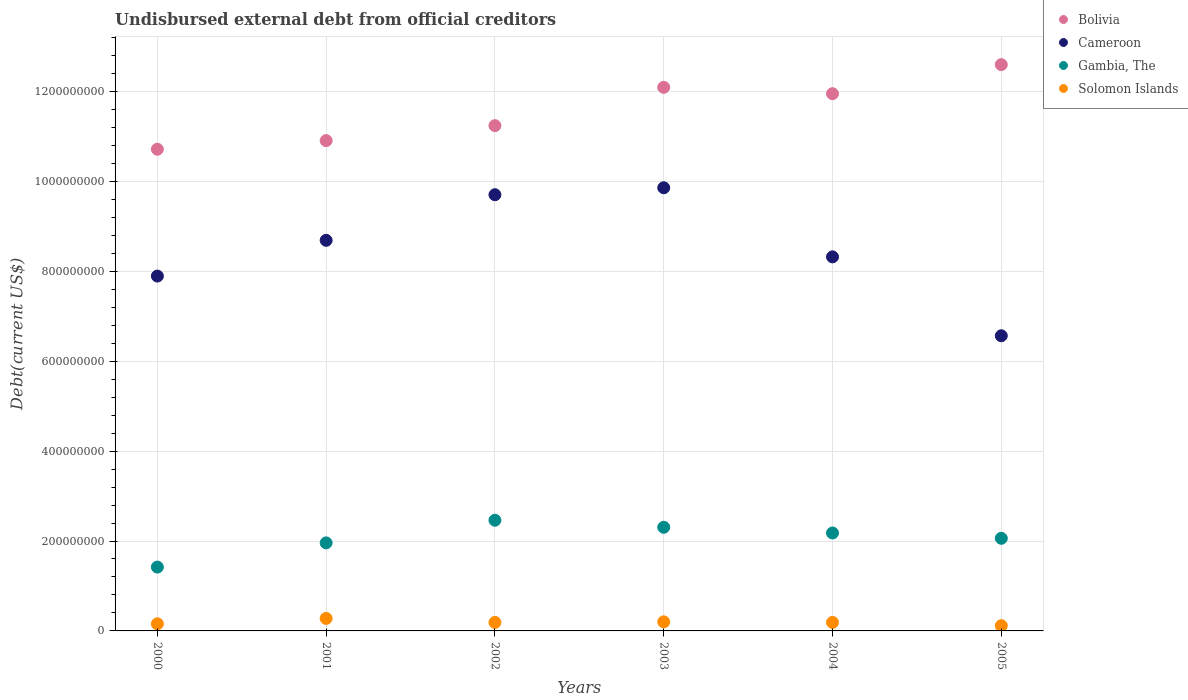How many different coloured dotlines are there?
Ensure brevity in your answer.  4. Is the number of dotlines equal to the number of legend labels?
Ensure brevity in your answer.  Yes. What is the total debt in Cameroon in 2004?
Provide a short and direct response. 8.32e+08. Across all years, what is the maximum total debt in Gambia, The?
Give a very brief answer. 2.46e+08. Across all years, what is the minimum total debt in Gambia, The?
Provide a short and direct response. 1.42e+08. What is the total total debt in Solomon Islands in the graph?
Provide a short and direct response. 1.13e+08. What is the difference between the total debt in Bolivia in 2000 and that in 2002?
Provide a short and direct response. -5.24e+07. What is the difference between the total debt in Cameroon in 2004 and the total debt in Gambia, The in 2005?
Offer a very short reply. 6.26e+08. What is the average total debt in Solomon Islands per year?
Provide a succinct answer. 1.89e+07. In the year 2001, what is the difference between the total debt in Solomon Islands and total debt in Gambia, The?
Give a very brief answer. -1.68e+08. In how many years, is the total debt in Bolivia greater than 1120000000 US$?
Give a very brief answer. 4. What is the ratio of the total debt in Bolivia in 2001 to that in 2003?
Ensure brevity in your answer.  0.9. Is the total debt in Solomon Islands in 2003 less than that in 2005?
Offer a terse response. No. What is the difference between the highest and the second highest total debt in Cameroon?
Your answer should be compact. 1.55e+07. What is the difference between the highest and the lowest total debt in Gambia, The?
Your response must be concise. 1.04e+08. Is the sum of the total debt in Gambia, The in 2002 and 2004 greater than the maximum total debt in Solomon Islands across all years?
Your answer should be compact. Yes. Is it the case that in every year, the sum of the total debt in Solomon Islands and total debt in Gambia, The  is greater than the total debt in Bolivia?
Offer a terse response. No. Does the total debt in Gambia, The monotonically increase over the years?
Your response must be concise. No. Is the total debt in Solomon Islands strictly greater than the total debt in Cameroon over the years?
Give a very brief answer. No. Is the total debt in Solomon Islands strictly less than the total debt in Bolivia over the years?
Keep it short and to the point. Yes. How many dotlines are there?
Offer a very short reply. 4. What is the difference between two consecutive major ticks on the Y-axis?
Make the answer very short. 2.00e+08. Does the graph contain grids?
Provide a short and direct response. Yes. How many legend labels are there?
Offer a terse response. 4. What is the title of the graph?
Provide a succinct answer. Undisbursed external debt from official creditors. What is the label or title of the Y-axis?
Offer a very short reply. Debt(current US$). What is the Debt(current US$) in Bolivia in 2000?
Provide a short and direct response. 1.07e+09. What is the Debt(current US$) in Cameroon in 2000?
Your response must be concise. 7.89e+08. What is the Debt(current US$) of Gambia, The in 2000?
Make the answer very short. 1.42e+08. What is the Debt(current US$) of Solomon Islands in 2000?
Your response must be concise. 1.58e+07. What is the Debt(current US$) in Bolivia in 2001?
Give a very brief answer. 1.09e+09. What is the Debt(current US$) of Cameroon in 2001?
Your answer should be very brief. 8.69e+08. What is the Debt(current US$) in Gambia, The in 2001?
Give a very brief answer. 1.96e+08. What is the Debt(current US$) in Solomon Islands in 2001?
Give a very brief answer. 2.78e+07. What is the Debt(current US$) in Bolivia in 2002?
Make the answer very short. 1.12e+09. What is the Debt(current US$) in Cameroon in 2002?
Offer a very short reply. 9.70e+08. What is the Debt(current US$) in Gambia, The in 2002?
Make the answer very short. 2.46e+08. What is the Debt(current US$) in Solomon Islands in 2002?
Offer a very short reply. 1.89e+07. What is the Debt(current US$) in Bolivia in 2003?
Give a very brief answer. 1.21e+09. What is the Debt(current US$) of Cameroon in 2003?
Provide a short and direct response. 9.86e+08. What is the Debt(current US$) of Gambia, The in 2003?
Provide a succinct answer. 2.31e+08. What is the Debt(current US$) in Solomon Islands in 2003?
Your answer should be very brief. 2.02e+07. What is the Debt(current US$) of Bolivia in 2004?
Make the answer very short. 1.19e+09. What is the Debt(current US$) of Cameroon in 2004?
Make the answer very short. 8.32e+08. What is the Debt(current US$) in Gambia, The in 2004?
Keep it short and to the point. 2.18e+08. What is the Debt(current US$) in Solomon Islands in 2004?
Offer a very short reply. 1.89e+07. What is the Debt(current US$) of Bolivia in 2005?
Your answer should be very brief. 1.26e+09. What is the Debt(current US$) of Cameroon in 2005?
Keep it short and to the point. 6.57e+08. What is the Debt(current US$) in Gambia, The in 2005?
Give a very brief answer. 2.06e+08. What is the Debt(current US$) in Solomon Islands in 2005?
Offer a terse response. 1.17e+07. Across all years, what is the maximum Debt(current US$) in Bolivia?
Provide a short and direct response. 1.26e+09. Across all years, what is the maximum Debt(current US$) in Cameroon?
Provide a short and direct response. 9.86e+08. Across all years, what is the maximum Debt(current US$) of Gambia, The?
Your answer should be very brief. 2.46e+08. Across all years, what is the maximum Debt(current US$) of Solomon Islands?
Keep it short and to the point. 2.78e+07. Across all years, what is the minimum Debt(current US$) in Bolivia?
Your response must be concise. 1.07e+09. Across all years, what is the minimum Debt(current US$) in Cameroon?
Keep it short and to the point. 6.57e+08. Across all years, what is the minimum Debt(current US$) of Gambia, The?
Ensure brevity in your answer.  1.42e+08. Across all years, what is the minimum Debt(current US$) in Solomon Islands?
Provide a short and direct response. 1.17e+07. What is the total Debt(current US$) of Bolivia in the graph?
Your answer should be compact. 6.95e+09. What is the total Debt(current US$) in Cameroon in the graph?
Keep it short and to the point. 5.10e+09. What is the total Debt(current US$) of Gambia, The in the graph?
Your answer should be compact. 1.24e+09. What is the total Debt(current US$) in Solomon Islands in the graph?
Your response must be concise. 1.13e+08. What is the difference between the Debt(current US$) of Bolivia in 2000 and that in 2001?
Your answer should be compact. -1.92e+07. What is the difference between the Debt(current US$) in Cameroon in 2000 and that in 2001?
Provide a short and direct response. -7.95e+07. What is the difference between the Debt(current US$) of Gambia, The in 2000 and that in 2001?
Make the answer very short. -5.39e+07. What is the difference between the Debt(current US$) in Solomon Islands in 2000 and that in 2001?
Keep it short and to the point. -1.20e+07. What is the difference between the Debt(current US$) of Bolivia in 2000 and that in 2002?
Provide a short and direct response. -5.24e+07. What is the difference between the Debt(current US$) in Cameroon in 2000 and that in 2002?
Give a very brief answer. -1.81e+08. What is the difference between the Debt(current US$) in Gambia, The in 2000 and that in 2002?
Give a very brief answer. -1.04e+08. What is the difference between the Debt(current US$) of Solomon Islands in 2000 and that in 2002?
Ensure brevity in your answer.  -3.08e+06. What is the difference between the Debt(current US$) of Bolivia in 2000 and that in 2003?
Ensure brevity in your answer.  -1.38e+08. What is the difference between the Debt(current US$) in Cameroon in 2000 and that in 2003?
Make the answer very short. -1.96e+08. What is the difference between the Debt(current US$) in Gambia, The in 2000 and that in 2003?
Offer a very short reply. -8.85e+07. What is the difference between the Debt(current US$) of Solomon Islands in 2000 and that in 2003?
Ensure brevity in your answer.  -4.37e+06. What is the difference between the Debt(current US$) of Bolivia in 2000 and that in 2004?
Give a very brief answer. -1.24e+08. What is the difference between the Debt(current US$) in Cameroon in 2000 and that in 2004?
Keep it short and to the point. -4.27e+07. What is the difference between the Debt(current US$) of Gambia, The in 2000 and that in 2004?
Your answer should be very brief. -7.58e+07. What is the difference between the Debt(current US$) of Solomon Islands in 2000 and that in 2004?
Ensure brevity in your answer.  -3.07e+06. What is the difference between the Debt(current US$) of Bolivia in 2000 and that in 2005?
Provide a succinct answer. -1.88e+08. What is the difference between the Debt(current US$) of Cameroon in 2000 and that in 2005?
Keep it short and to the point. 1.33e+08. What is the difference between the Debt(current US$) of Gambia, The in 2000 and that in 2005?
Keep it short and to the point. -6.40e+07. What is the difference between the Debt(current US$) of Solomon Islands in 2000 and that in 2005?
Provide a short and direct response. 4.14e+06. What is the difference between the Debt(current US$) of Bolivia in 2001 and that in 2002?
Provide a short and direct response. -3.33e+07. What is the difference between the Debt(current US$) of Cameroon in 2001 and that in 2002?
Make the answer very short. -1.01e+08. What is the difference between the Debt(current US$) in Gambia, The in 2001 and that in 2002?
Provide a succinct answer. -5.03e+07. What is the difference between the Debt(current US$) in Solomon Islands in 2001 and that in 2002?
Your answer should be very brief. 8.89e+06. What is the difference between the Debt(current US$) of Bolivia in 2001 and that in 2003?
Provide a short and direct response. -1.18e+08. What is the difference between the Debt(current US$) in Cameroon in 2001 and that in 2003?
Offer a terse response. -1.17e+08. What is the difference between the Debt(current US$) of Gambia, The in 2001 and that in 2003?
Your answer should be compact. -3.47e+07. What is the difference between the Debt(current US$) in Solomon Islands in 2001 and that in 2003?
Make the answer very short. 7.60e+06. What is the difference between the Debt(current US$) of Bolivia in 2001 and that in 2004?
Provide a short and direct response. -1.04e+08. What is the difference between the Debt(current US$) in Cameroon in 2001 and that in 2004?
Your response must be concise. 3.68e+07. What is the difference between the Debt(current US$) of Gambia, The in 2001 and that in 2004?
Your answer should be compact. -2.20e+07. What is the difference between the Debt(current US$) of Solomon Islands in 2001 and that in 2004?
Ensure brevity in your answer.  8.90e+06. What is the difference between the Debt(current US$) of Bolivia in 2001 and that in 2005?
Provide a short and direct response. -1.69e+08. What is the difference between the Debt(current US$) in Cameroon in 2001 and that in 2005?
Your answer should be compact. 2.12e+08. What is the difference between the Debt(current US$) of Gambia, The in 2001 and that in 2005?
Your response must be concise. -1.02e+07. What is the difference between the Debt(current US$) in Solomon Islands in 2001 and that in 2005?
Provide a short and direct response. 1.61e+07. What is the difference between the Debt(current US$) in Bolivia in 2002 and that in 2003?
Your response must be concise. -8.52e+07. What is the difference between the Debt(current US$) in Cameroon in 2002 and that in 2003?
Offer a very short reply. -1.55e+07. What is the difference between the Debt(current US$) in Gambia, The in 2002 and that in 2003?
Keep it short and to the point. 1.56e+07. What is the difference between the Debt(current US$) in Solomon Islands in 2002 and that in 2003?
Offer a very short reply. -1.30e+06. What is the difference between the Debt(current US$) of Bolivia in 2002 and that in 2004?
Your response must be concise. -7.11e+07. What is the difference between the Debt(current US$) in Cameroon in 2002 and that in 2004?
Ensure brevity in your answer.  1.38e+08. What is the difference between the Debt(current US$) of Gambia, The in 2002 and that in 2004?
Make the answer very short. 2.83e+07. What is the difference between the Debt(current US$) in Solomon Islands in 2002 and that in 2004?
Provide a short and direct response. 9000. What is the difference between the Debt(current US$) of Bolivia in 2002 and that in 2005?
Your response must be concise. -1.36e+08. What is the difference between the Debt(current US$) in Cameroon in 2002 and that in 2005?
Offer a terse response. 3.14e+08. What is the difference between the Debt(current US$) in Gambia, The in 2002 and that in 2005?
Offer a terse response. 4.01e+07. What is the difference between the Debt(current US$) in Solomon Islands in 2002 and that in 2005?
Offer a very short reply. 7.22e+06. What is the difference between the Debt(current US$) of Bolivia in 2003 and that in 2004?
Provide a short and direct response. 1.41e+07. What is the difference between the Debt(current US$) in Cameroon in 2003 and that in 2004?
Your response must be concise. 1.54e+08. What is the difference between the Debt(current US$) in Gambia, The in 2003 and that in 2004?
Ensure brevity in your answer.  1.27e+07. What is the difference between the Debt(current US$) of Solomon Islands in 2003 and that in 2004?
Give a very brief answer. 1.30e+06. What is the difference between the Debt(current US$) in Bolivia in 2003 and that in 2005?
Ensure brevity in your answer.  -5.05e+07. What is the difference between the Debt(current US$) of Cameroon in 2003 and that in 2005?
Provide a short and direct response. 3.29e+08. What is the difference between the Debt(current US$) in Gambia, The in 2003 and that in 2005?
Make the answer very short. 2.45e+07. What is the difference between the Debt(current US$) of Solomon Islands in 2003 and that in 2005?
Your answer should be very brief. 8.52e+06. What is the difference between the Debt(current US$) in Bolivia in 2004 and that in 2005?
Provide a short and direct response. -6.46e+07. What is the difference between the Debt(current US$) of Cameroon in 2004 and that in 2005?
Your answer should be very brief. 1.76e+08. What is the difference between the Debt(current US$) in Gambia, The in 2004 and that in 2005?
Your answer should be very brief. 1.18e+07. What is the difference between the Debt(current US$) of Solomon Islands in 2004 and that in 2005?
Ensure brevity in your answer.  7.21e+06. What is the difference between the Debt(current US$) in Bolivia in 2000 and the Debt(current US$) in Cameroon in 2001?
Offer a terse response. 2.03e+08. What is the difference between the Debt(current US$) in Bolivia in 2000 and the Debt(current US$) in Gambia, The in 2001?
Your response must be concise. 8.76e+08. What is the difference between the Debt(current US$) in Bolivia in 2000 and the Debt(current US$) in Solomon Islands in 2001?
Give a very brief answer. 1.04e+09. What is the difference between the Debt(current US$) in Cameroon in 2000 and the Debt(current US$) in Gambia, The in 2001?
Give a very brief answer. 5.93e+08. What is the difference between the Debt(current US$) of Cameroon in 2000 and the Debt(current US$) of Solomon Islands in 2001?
Offer a terse response. 7.62e+08. What is the difference between the Debt(current US$) in Gambia, The in 2000 and the Debt(current US$) in Solomon Islands in 2001?
Offer a very short reply. 1.14e+08. What is the difference between the Debt(current US$) of Bolivia in 2000 and the Debt(current US$) of Cameroon in 2002?
Keep it short and to the point. 1.01e+08. What is the difference between the Debt(current US$) in Bolivia in 2000 and the Debt(current US$) in Gambia, The in 2002?
Offer a terse response. 8.25e+08. What is the difference between the Debt(current US$) of Bolivia in 2000 and the Debt(current US$) of Solomon Islands in 2002?
Your answer should be compact. 1.05e+09. What is the difference between the Debt(current US$) of Cameroon in 2000 and the Debt(current US$) of Gambia, The in 2002?
Provide a short and direct response. 5.43e+08. What is the difference between the Debt(current US$) in Cameroon in 2000 and the Debt(current US$) in Solomon Islands in 2002?
Ensure brevity in your answer.  7.70e+08. What is the difference between the Debt(current US$) in Gambia, The in 2000 and the Debt(current US$) in Solomon Islands in 2002?
Give a very brief answer. 1.23e+08. What is the difference between the Debt(current US$) in Bolivia in 2000 and the Debt(current US$) in Cameroon in 2003?
Make the answer very short. 8.57e+07. What is the difference between the Debt(current US$) of Bolivia in 2000 and the Debt(current US$) of Gambia, The in 2003?
Make the answer very short. 8.41e+08. What is the difference between the Debt(current US$) in Bolivia in 2000 and the Debt(current US$) in Solomon Islands in 2003?
Keep it short and to the point. 1.05e+09. What is the difference between the Debt(current US$) of Cameroon in 2000 and the Debt(current US$) of Gambia, The in 2003?
Ensure brevity in your answer.  5.59e+08. What is the difference between the Debt(current US$) of Cameroon in 2000 and the Debt(current US$) of Solomon Islands in 2003?
Ensure brevity in your answer.  7.69e+08. What is the difference between the Debt(current US$) in Gambia, The in 2000 and the Debt(current US$) in Solomon Islands in 2003?
Give a very brief answer. 1.22e+08. What is the difference between the Debt(current US$) in Bolivia in 2000 and the Debt(current US$) in Cameroon in 2004?
Provide a short and direct response. 2.39e+08. What is the difference between the Debt(current US$) of Bolivia in 2000 and the Debt(current US$) of Gambia, The in 2004?
Your answer should be very brief. 8.54e+08. What is the difference between the Debt(current US$) of Bolivia in 2000 and the Debt(current US$) of Solomon Islands in 2004?
Offer a terse response. 1.05e+09. What is the difference between the Debt(current US$) in Cameroon in 2000 and the Debt(current US$) in Gambia, The in 2004?
Your answer should be compact. 5.71e+08. What is the difference between the Debt(current US$) of Cameroon in 2000 and the Debt(current US$) of Solomon Islands in 2004?
Offer a very short reply. 7.70e+08. What is the difference between the Debt(current US$) of Gambia, The in 2000 and the Debt(current US$) of Solomon Islands in 2004?
Your response must be concise. 1.23e+08. What is the difference between the Debt(current US$) in Bolivia in 2000 and the Debt(current US$) in Cameroon in 2005?
Offer a terse response. 4.15e+08. What is the difference between the Debt(current US$) in Bolivia in 2000 and the Debt(current US$) in Gambia, The in 2005?
Give a very brief answer. 8.65e+08. What is the difference between the Debt(current US$) in Bolivia in 2000 and the Debt(current US$) in Solomon Islands in 2005?
Give a very brief answer. 1.06e+09. What is the difference between the Debt(current US$) of Cameroon in 2000 and the Debt(current US$) of Gambia, The in 2005?
Provide a succinct answer. 5.83e+08. What is the difference between the Debt(current US$) of Cameroon in 2000 and the Debt(current US$) of Solomon Islands in 2005?
Your answer should be compact. 7.78e+08. What is the difference between the Debt(current US$) of Gambia, The in 2000 and the Debt(current US$) of Solomon Islands in 2005?
Provide a short and direct response. 1.30e+08. What is the difference between the Debt(current US$) in Bolivia in 2001 and the Debt(current US$) in Cameroon in 2002?
Keep it short and to the point. 1.20e+08. What is the difference between the Debt(current US$) in Bolivia in 2001 and the Debt(current US$) in Gambia, The in 2002?
Offer a very short reply. 8.44e+08. What is the difference between the Debt(current US$) in Bolivia in 2001 and the Debt(current US$) in Solomon Islands in 2002?
Provide a short and direct response. 1.07e+09. What is the difference between the Debt(current US$) in Cameroon in 2001 and the Debt(current US$) in Gambia, The in 2002?
Provide a short and direct response. 6.23e+08. What is the difference between the Debt(current US$) in Cameroon in 2001 and the Debt(current US$) in Solomon Islands in 2002?
Provide a short and direct response. 8.50e+08. What is the difference between the Debt(current US$) of Gambia, The in 2001 and the Debt(current US$) of Solomon Islands in 2002?
Your answer should be very brief. 1.77e+08. What is the difference between the Debt(current US$) of Bolivia in 2001 and the Debt(current US$) of Cameroon in 2003?
Provide a short and direct response. 1.05e+08. What is the difference between the Debt(current US$) of Bolivia in 2001 and the Debt(current US$) of Gambia, The in 2003?
Keep it short and to the point. 8.60e+08. What is the difference between the Debt(current US$) in Bolivia in 2001 and the Debt(current US$) in Solomon Islands in 2003?
Your answer should be very brief. 1.07e+09. What is the difference between the Debt(current US$) in Cameroon in 2001 and the Debt(current US$) in Gambia, The in 2003?
Make the answer very short. 6.38e+08. What is the difference between the Debt(current US$) in Cameroon in 2001 and the Debt(current US$) in Solomon Islands in 2003?
Keep it short and to the point. 8.49e+08. What is the difference between the Debt(current US$) in Gambia, The in 2001 and the Debt(current US$) in Solomon Islands in 2003?
Keep it short and to the point. 1.76e+08. What is the difference between the Debt(current US$) of Bolivia in 2001 and the Debt(current US$) of Cameroon in 2004?
Your answer should be very brief. 2.59e+08. What is the difference between the Debt(current US$) in Bolivia in 2001 and the Debt(current US$) in Gambia, The in 2004?
Give a very brief answer. 8.73e+08. What is the difference between the Debt(current US$) in Bolivia in 2001 and the Debt(current US$) in Solomon Islands in 2004?
Your answer should be very brief. 1.07e+09. What is the difference between the Debt(current US$) of Cameroon in 2001 and the Debt(current US$) of Gambia, The in 2004?
Make the answer very short. 6.51e+08. What is the difference between the Debt(current US$) of Cameroon in 2001 and the Debt(current US$) of Solomon Islands in 2004?
Ensure brevity in your answer.  8.50e+08. What is the difference between the Debt(current US$) of Gambia, The in 2001 and the Debt(current US$) of Solomon Islands in 2004?
Make the answer very short. 1.77e+08. What is the difference between the Debt(current US$) of Bolivia in 2001 and the Debt(current US$) of Cameroon in 2005?
Offer a very short reply. 4.34e+08. What is the difference between the Debt(current US$) in Bolivia in 2001 and the Debt(current US$) in Gambia, The in 2005?
Offer a very short reply. 8.85e+08. What is the difference between the Debt(current US$) in Bolivia in 2001 and the Debt(current US$) in Solomon Islands in 2005?
Make the answer very short. 1.08e+09. What is the difference between the Debt(current US$) of Cameroon in 2001 and the Debt(current US$) of Gambia, The in 2005?
Your answer should be very brief. 6.63e+08. What is the difference between the Debt(current US$) of Cameroon in 2001 and the Debt(current US$) of Solomon Islands in 2005?
Provide a short and direct response. 8.57e+08. What is the difference between the Debt(current US$) in Gambia, The in 2001 and the Debt(current US$) in Solomon Islands in 2005?
Provide a succinct answer. 1.84e+08. What is the difference between the Debt(current US$) in Bolivia in 2002 and the Debt(current US$) in Cameroon in 2003?
Offer a terse response. 1.38e+08. What is the difference between the Debt(current US$) in Bolivia in 2002 and the Debt(current US$) in Gambia, The in 2003?
Make the answer very short. 8.93e+08. What is the difference between the Debt(current US$) in Bolivia in 2002 and the Debt(current US$) in Solomon Islands in 2003?
Offer a terse response. 1.10e+09. What is the difference between the Debt(current US$) in Cameroon in 2002 and the Debt(current US$) in Gambia, The in 2003?
Your response must be concise. 7.40e+08. What is the difference between the Debt(current US$) of Cameroon in 2002 and the Debt(current US$) of Solomon Islands in 2003?
Keep it short and to the point. 9.50e+08. What is the difference between the Debt(current US$) in Gambia, The in 2002 and the Debt(current US$) in Solomon Islands in 2003?
Keep it short and to the point. 2.26e+08. What is the difference between the Debt(current US$) of Bolivia in 2002 and the Debt(current US$) of Cameroon in 2004?
Provide a short and direct response. 2.92e+08. What is the difference between the Debt(current US$) of Bolivia in 2002 and the Debt(current US$) of Gambia, The in 2004?
Keep it short and to the point. 9.06e+08. What is the difference between the Debt(current US$) of Bolivia in 2002 and the Debt(current US$) of Solomon Islands in 2004?
Give a very brief answer. 1.10e+09. What is the difference between the Debt(current US$) in Cameroon in 2002 and the Debt(current US$) in Gambia, The in 2004?
Offer a terse response. 7.52e+08. What is the difference between the Debt(current US$) in Cameroon in 2002 and the Debt(current US$) in Solomon Islands in 2004?
Your answer should be compact. 9.51e+08. What is the difference between the Debt(current US$) in Gambia, The in 2002 and the Debt(current US$) in Solomon Islands in 2004?
Your response must be concise. 2.27e+08. What is the difference between the Debt(current US$) in Bolivia in 2002 and the Debt(current US$) in Cameroon in 2005?
Ensure brevity in your answer.  4.67e+08. What is the difference between the Debt(current US$) of Bolivia in 2002 and the Debt(current US$) of Gambia, The in 2005?
Keep it short and to the point. 9.18e+08. What is the difference between the Debt(current US$) in Bolivia in 2002 and the Debt(current US$) in Solomon Islands in 2005?
Offer a very short reply. 1.11e+09. What is the difference between the Debt(current US$) in Cameroon in 2002 and the Debt(current US$) in Gambia, The in 2005?
Give a very brief answer. 7.64e+08. What is the difference between the Debt(current US$) of Cameroon in 2002 and the Debt(current US$) of Solomon Islands in 2005?
Provide a succinct answer. 9.59e+08. What is the difference between the Debt(current US$) in Gambia, The in 2002 and the Debt(current US$) in Solomon Islands in 2005?
Ensure brevity in your answer.  2.34e+08. What is the difference between the Debt(current US$) in Bolivia in 2003 and the Debt(current US$) in Cameroon in 2004?
Keep it short and to the point. 3.77e+08. What is the difference between the Debt(current US$) in Bolivia in 2003 and the Debt(current US$) in Gambia, The in 2004?
Your answer should be compact. 9.91e+08. What is the difference between the Debt(current US$) in Bolivia in 2003 and the Debt(current US$) in Solomon Islands in 2004?
Provide a succinct answer. 1.19e+09. What is the difference between the Debt(current US$) in Cameroon in 2003 and the Debt(current US$) in Gambia, The in 2004?
Offer a very short reply. 7.68e+08. What is the difference between the Debt(current US$) in Cameroon in 2003 and the Debt(current US$) in Solomon Islands in 2004?
Provide a short and direct response. 9.67e+08. What is the difference between the Debt(current US$) in Gambia, The in 2003 and the Debt(current US$) in Solomon Islands in 2004?
Ensure brevity in your answer.  2.12e+08. What is the difference between the Debt(current US$) of Bolivia in 2003 and the Debt(current US$) of Cameroon in 2005?
Make the answer very short. 5.53e+08. What is the difference between the Debt(current US$) in Bolivia in 2003 and the Debt(current US$) in Gambia, The in 2005?
Provide a short and direct response. 1.00e+09. What is the difference between the Debt(current US$) in Bolivia in 2003 and the Debt(current US$) in Solomon Islands in 2005?
Provide a succinct answer. 1.20e+09. What is the difference between the Debt(current US$) of Cameroon in 2003 and the Debt(current US$) of Gambia, The in 2005?
Offer a terse response. 7.80e+08. What is the difference between the Debt(current US$) of Cameroon in 2003 and the Debt(current US$) of Solomon Islands in 2005?
Your answer should be compact. 9.74e+08. What is the difference between the Debt(current US$) in Gambia, The in 2003 and the Debt(current US$) in Solomon Islands in 2005?
Ensure brevity in your answer.  2.19e+08. What is the difference between the Debt(current US$) of Bolivia in 2004 and the Debt(current US$) of Cameroon in 2005?
Keep it short and to the point. 5.38e+08. What is the difference between the Debt(current US$) in Bolivia in 2004 and the Debt(current US$) in Gambia, The in 2005?
Your response must be concise. 9.89e+08. What is the difference between the Debt(current US$) in Bolivia in 2004 and the Debt(current US$) in Solomon Islands in 2005?
Keep it short and to the point. 1.18e+09. What is the difference between the Debt(current US$) in Cameroon in 2004 and the Debt(current US$) in Gambia, The in 2005?
Offer a terse response. 6.26e+08. What is the difference between the Debt(current US$) in Cameroon in 2004 and the Debt(current US$) in Solomon Islands in 2005?
Ensure brevity in your answer.  8.20e+08. What is the difference between the Debt(current US$) in Gambia, The in 2004 and the Debt(current US$) in Solomon Islands in 2005?
Your answer should be very brief. 2.06e+08. What is the average Debt(current US$) of Bolivia per year?
Ensure brevity in your answer.  1.16e+09. What is the average Debt(current US$) in Cameroon per year?
Give a very brief answer. 8.50e+08. What is the average Debt(current US$) in Gambia, The per year?
Your answer should be compact. 2.06e+08. What is the average Debt(current US$) in Solomon Islands per year?
Ensure brevity in your answer.  1.89e+07. In the year 2000, what is the difference between the Debt(current US$) in Bolivia and Debt(current US$) in Cameroon?
Ensure brevity in your answer.  2.82e+08. In the year 2000, what is the difference between the Debt(current US$) of Bolivia and Debt(current US$) of Gambia, The?
Provide a succinct answer. 9.29e+08. In the year 2000, what is the difference between the Debt(current US$) of Bolivia and Debt(current US$) of Solomon Islands?
Your answer should be compact. 1.06e+09. In the year 2000, what is the difference between the Debt(current US$) of Cameroon and Debt(current US$) of Gambia, The?
Your response must be concise. 6.47e+08. In the year 2000, what is the difference between the Debt(current US$) in Cameroon and Debt(current US$) in Solomon Islands?
Offer a terse response. 7.73e+08. In the year 2000, what is the difference between the Debt(current US$) of Gambia, The and Debt(current US$) of Solomon Islands?
Ensure brevity in your answer.  1.26e+08. In the year 2001, what is the difference between the Debt(current US$) in Bolivia and Debt(current US$) in Cameroon?
Offer a terse response. 2.22e+08. In the year 2001, what is the difference between the Debt(current US$) in Bolivia and Debt(current US$) in Gambia, The?
Provide a short and direct response. 8.95e+08. In the year 2001, what is the difference between the Debt(current US$) of Bolivia and Debt(current US$) of Solomon Islands?
Ensure brevity in your answer.  1.06e+09. In the year 2001, what is the difference between the Debt(current US$) in Cameroon and Debt(current US$) in Gambia, The?
Your response must be concise. 6.73e+08. In the year 2001, what is the difference between the Debt(current US$) in Cameroon and Debt(current US$) in Solomon Islands?
Offer a very short reply. 8.41e+08. In the year 2001, what is the difference between the Debt(current US$) of Gambia, The and Debt(current US$) of Solomon Islands?
Your response must be concise. 1.68e+08. In the year 2002, what is the difference between the Debt(current US$) in Bolivia and Debt(current US$) in Cameroon?
Ensure brevity in your answer.  1.54e+08. In the year 2002, what is the difference between the Debt(current US$) in Bolivia and Debt(current US$) in Gambia, The?
Provide a short and direct response. 8.78e+08. In the year 2002, what is the difference between the Debt(current US$) of Bolivia and Debt(current US$) of Solomon Islands?
Your response must be concise. 1.10e+09. In the year 2002, what is the difference between the Debt(current US$) in Cameroon and Debt(current US$) in Gambia, The?
Keep it short and to the point. 7.24e+08. In the year 2002, what is the difference between the Debt(current US$) in Cameroon and Debt(current US$) in Solomon Islands?
Make the answer very short. 9.51e+08. In the year 2002, what is the difference between the Debt(current US$) in Gambia, The and Debt(current US$) in Solomon Islands?
Provide a short and direct response. 2.27e+08. In the year 2003, what is the difference between the Debt(current US$) in Bolivia and Debt(current US$) in Cameroon?
Your answer should be compact. 2.23e+08. In the year 2003, what is the difference between the Debt(current US$) of Bolivia and Debt(current US$) of Gambia, The?
Make the answer very short. 9.79e+08. In the year 2003, what is the difference between the Debt(current US$) in Bolivia and Debt(current US$) in Solomon Islands?
Offer a very short reply. 1.19e+09. In the year 2003, what is the difference between the Debt(current US$) in Cameroon and Debt(current US$) in Gambia, The?
Ensure brevity in your answer.  7.55e+08. In the year 2003, what is the difference between the Debt(current US$) in Cameroon and Debt(current US$) in Solomon Islands?
Your answer should be compact. 9.66e+08. In the year 2003, what is the difference between the Debt(current US$) of Gambia, The and Debt(current US$) of Solomon Islands?
Keep it short and to the point. 2.10e+08. In the year 2004, what is the difference between the Debt(current US$) of Bolivia and Debt(current US$) of Cameroon?
Offer a terse response. 3.63e+08. In the year 2004, what is the difference between the Debt(current US$) in Bolivia and Debt(current US$) in Gambia, The?
Provide a succinct answer. 9.77e+08. In the year 2004, what is the difference between the Debt(current US$) of Bolivia and Debt(current US$) of Solomon Islands?
Keep it short and to the point. 1.18e+09. In the year 2004, what is the difference between the Debt(current US$) in Cameroon and Debt(current US$) in Gambia, The?
Give a very brief answer. 6.14e+08. In the year 2004, what is the difference between the Debt(current US$) of Cameroon and Debt(current US$) of Solomon Islands?
Ensure brevity in your answer.  8.13e+08. In the year 2004, what is the difference between the Debt(current US$) in Gambia, The and Debt(current US$) in Solomon Islands?
Provide a short and direct response. 1.99e+08. In the year 2005, what is the difference between the Debt(current US$) of Bolivia and Debt(current US$) of Cameroon?
Your answer should be compact. 6.03e+08. In the year 2005, what is the difference between the Debt(current US$) in Bolivia and Debt(current US$) in Gambia, The?
Provide a short and direct response. 1.05e+09. In the year 2005, what is the difference between the Debt(current US$) of Bolivia and Debt(current US$) of Solomon Islands?
Your answer should be very brief. 1.25e+09. In the year 2005, what is the difference between the Debt(current US$) in Cameroon and Debt(current US$) in Gambia, The?
Your answer should be very brief. 4.50e+08. In the year 2005, what is the difference between the Debt(current US$) of Cameroon and Debt(current US$) of Solomon Islands?
Your response must be concise. 6.45e+08. In the year 2005, what is the difference between the Debt(current US$) of Gambia, The and Debt(current US$) of Solomon Islands?
Your response must be concise. 1.94e+08. What is the ratio of the Debt(current US$) in Bolivia in 2000 to that in 2001?
Provide a short and direct response. 0.98. What is the ratio of the Debt(current US$) of Cameroon in 2000 to that in 2001?
Offer a very short reply. 0.91. What is the ratio of the Debt(current US$) in Gambia, The in 2000 to that in 2001?
Make the answer very short. 0.72. What is the ratio of the Debt(current US$) of Solomon Islands in 2000 to that in 2001?
Your answer should be very brief. 0.57. What is the ratio of the Debt(current US$) of Bolivia in 2000 to that in 2002?
Offer a terse response. 0.95. What is the ratio of the Debt(current US$) of Cameroon in 2000 to that in 2002?
Keep it short and to the point. 0.81. What is the ratio of the Debt(current US$) in Gambia, The in 2000 to that in 2002?
Provide a succinct answer. 0.58. What is the ratio of the Debt(current US$) in Solomon Islands in 2000 to that in 2002?
Your response must be concise. 0.84. What is the ratio of the Debt(current US$) of Bolivia in 2000 to that in 2003?
Provide a short and direct response. 0.89. What is the ratio of the Debt(current US$) of Cameroon in 2000 to that in 2003?
Your response must be concise. 0.8. What is the ratio of the Debt(current US$) in Gambia, The in 2000 to that in 2003?
Offer a very short reply. 0.62. What is the ratio of the Debt(current US$) of Solomon Islands in 2000 to that in 2003?
Give a very brief answer. 0.78. What is the ratio of the Debt(current US$) in Bolivia in 2000 to that in 2004?
Offer a very short reply. 0.9. What is the ratio of the Debt(current US$) of Cameroon in 2000 to that in 2004?
Your answer should be compact. 0.95. What is the ratio of the Debt(current US$) of Gambia, The in 2000 to that in 2004?
Give a very brief answer. 0.65. What is the ratio of the Debt(current US$) of Solomon Islands in 2000 to that in 2004?
Ensure brevity in your answer.  0.84. What is the ratio of the Debt(current US$) of Bolivia in 2000 to that in 2005?
Make the answer very short. 0.85. What is the ratio of the Debt(current US$) of Cameroon in 2000 to that in 2005?
Give a very brief answer. 1.2. What is the ratio of the Debt(current US$) of Gambia, The in 2000 to that in 2005?
Keep it short and to the point. 0.69. What is the ratio of the Debt(current US$) in Solomon Islands in 2000 to that in 2005?
Your response must be concise. 1.35. What is the ratio of the Debt(current US$) of Bolivia in 2001 to that in 2002?
Your answer should be compact. 0.97. What is the ratio of the Debt(current US$) in Cameroon in 2001 to that in 2002?
Ensure brevity in your answer.  0.9. What is the ratio of the Debt(current US$) in Gambia, The in 2001 to that in 2002?
Give a very brief answer. 0.8. What is the ratio of the Debt(current US$) of Solomon Islands in 2001 to that in 2002?
Your answer should be compact. 1.47. What is the ratio of the Debt(current US$) in Bolivia in 2001 to that in 2003?
Offer a very short reply. 0.9. What is the ratio of the Debt(current US$) of Cameroon in 2001 to that in 2003?
Offer a terse response. 0.88. What is the ratio of the Debt(current US$) in Gambia, The in 2001 to that in 2003?
Your answer should be very brief. 0.85. What is the ratio of the Debt(current US$) of Solomon Islands in 2001 to that in 2003?
Make the answer very short. 1.38. What is the ratio of the Debt(current US$) of Bolivia in 2001 to that in 2004?
Your answer should be very brief. 0.91. What is the ratio of the Debt(current US$) in Cameroon in 2001 to that in 2004?
Your response must be concise. 1.04. What is the ratio of the Debt(current US$) in Gambia, The in 2001 to that in 2004?
Your answer should be compact. 0.9. What is the ratio of the Debt(current US$) of Solomon Islands in 2001 to that in 2004?
Provide a succinct answer. 1.47. What is the ratio of the Debt(current US$) of Bolivia in 2001 to that in 2005?
Keep it short and to the point. 0.87. What is the ratio of the Debt(current US$) in Cameroon in 2001 to that in 2005?
Offer a terse response. 1.32. What is the ratio of the Debt(current US$) of Gambia, The in 2001 to that in 2005?
Your answer should be compact. 0.95. What is the ratio of the Debt(current US$) of Solomon Islands in 2001 to that in 2005?
Ensure brevity in your answer.  2.38. What is the ratio of the Debt(current US$) in Bolivia in 2002 to that in 2003?
Give a very brief answer. 0.93. What is the ratio of the Debt(current US$) in Cameroon in 2002 to that in 2003?
Provide a succinct answer. 0.98. What is the ratio of the Debt(current US$) in Gambia, The in 2002 to that in 2003?
Give a very brief answer. 1.07. What is the ratio of the Debt(current US$) in Solomon Islands in 2002 to that in 2003?
Provide a succinct answer. 0.94. What is the ratio of the Debt(current US$) of Bolivia in 2002 to that in 2004?
Offer a terse response. 0.94. What is the ratio of the Debt(current US$) of Cameroon in 2002 to that in 2004?
Provide a succinct answer. 1.17. What is the ratio of the Debt(current US$) of Gambia, The in 2002 to that in 2004?
Your answer should be compact. 1.13. What is the ratio of the Debt(current US$) of Solomon Islands in 2002 to that in 2004?
Your answer should be very brief. 1. What is the ratio of the Debt(current US$) of Bolivia in 2002 to that in 2005?
Make the answer very short. 0.89. What is the ratio of the Debt(current US$) in Cameroon in 2002 to that in 2005?
Keep it short and to the point. 1.48. What is the ratio of the Debt(current US$) of Gambia, The in 2002 to that in 2005?
Provide a succinct answer. 1.19. What is the ratio of the Debt(current US$) in Solomon Islands in 2002 to that in 2005?
Offer a terse response. 1.62. What is the ratio of the Debt(current US$) of Bolivia in 2003 to that in 2004?
Keep it short and to the point. 1.01. What is the ratio of the Debt(current US$) in Cameroon in 2003 to that in 2004?
Ensure brevity in your answer.  1.18. What is the ratio of the Debt(current US$) in Gambia, The in 2003 to that in 2004?
Your response must be concise. 1.06. What is the ratio of the Debt(current US$) of Solomon Islands in 2003 to that in 2004?
Ensure brevity in your answer.  1.07. What is the ratio of the Debt(current US$) of Bolivia in 2003 to that in 2005?
Offer a terse response. 0.96. What is the ratio of the Debt(current US$) of Cameroon in 2003 to that in 2005?
Ensure brevity in your answer.  1.5. What is the ratio of the Debt(current US$) in Gambia, The in 2003 to that in 2005?
Ensure brevity in your answer.  1.12. What is the ratio of the Debt(current US$) in Solomon Islands in 2003 to that in 2005?
Offer a very short reply. 1.73. What is the ratio of the Debt(current US$) in Bolivia in 2004 to that in 2005?
Provide a succinct answer. 0.95. What is the ratio of the Debt(current US$) in Cameroon in 2004 to that in 2005?
Your answer should be compact. 1.27. What is the ratio of the Debt(current US$) of Gambia, The in 2004 to that in 2005?
Provide a short and direct response. 1.06. What is the ratio of the Debt(current US$) in Solomon Islands in 2004 to that in 2005?
Provide a short and direct response. 1.62. What is the difference between the highest and the second highest Debt(current US$) in Bolivia?
Make the answer very short. 5.05e+07. What is the difference between the highest and the second highest Debt(current US$) of Cameroon?
Offer a very short reply. 1.55e+07. What is the difference between the highest and the second highest Debt(current US$) of Gambia, The?
Provide a succinct answer. 1.56e+07. What is the difference between the highest and the second highest Debt(current US$) in Solomon Islands?
Offer a very short reply. 7.60e+06. What is the difference between the highest and the lowest Debt(current US$) in Bolivia?
Make the answer very short. 1.88e+08. What is the difference between the highest and the lowest Debt(current US$) of Cameroon?
Make the answer very short. 3.29e+08. What is the difference between the highest and the lowest Debt(current US$) of Gambia, The?
Ensure brevity in your answer.  1.04e+08. What is the difference between the highest and the lowest Debt(current US$) in Solomon Islands?
Offer a very short reply. 1.61e+07. 